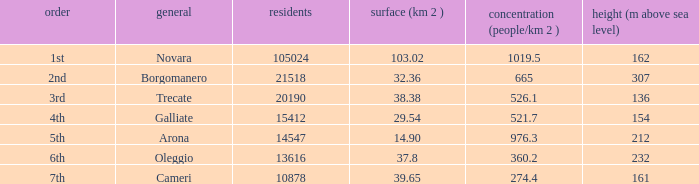Where does the common of Galliate rank in population? 4th. 